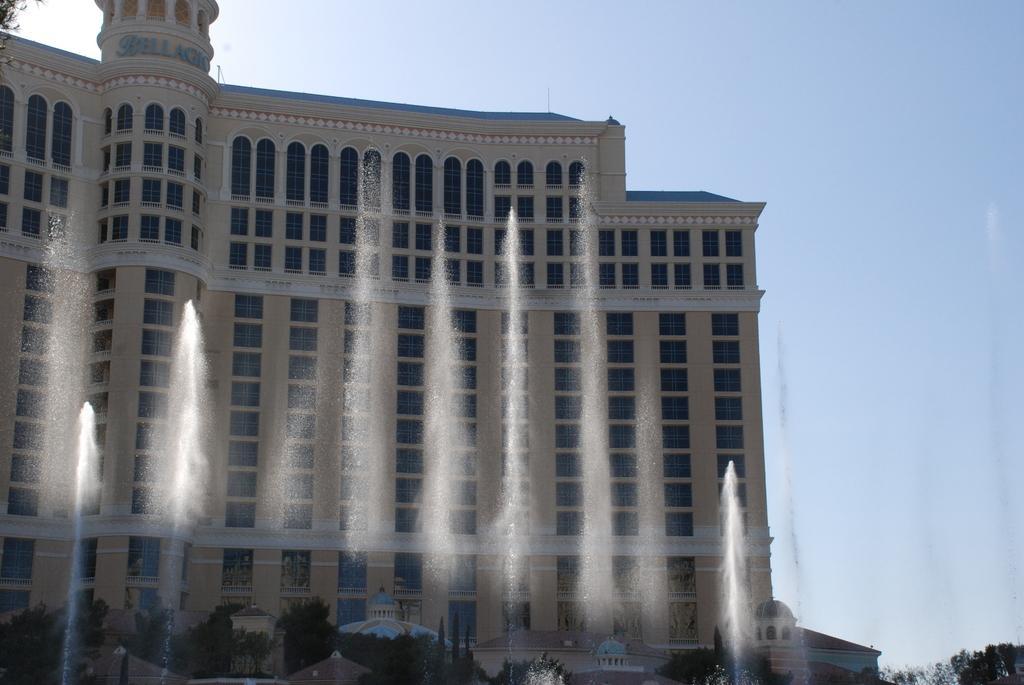In one or two sentences, can you explain what this image depicts? In this image in the center there is a building, and in the foreground there are some waterfalls, trees, buildings and some other objects. In the background there is sky. 